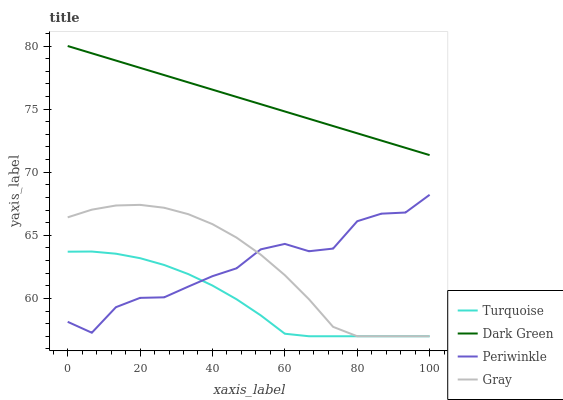Does Turquoise have the minimum area under the curve?
Answer yes or no. Yes. Does Dark Green have the maximum area under the curve?
Answer yes or no. Yes. Does Periwinkle have the minimum area under the curve?
Answer yes or no. No. Does Periwinkle have the maximum area under the curve?
Answer yes or no. No. Is Dark Green the smoothest?
Answer yes or no. Yes. Is Periwinkle the roughest?
Answer yes or no. Yes. Is Turquoise the smoothest?
Answer yes or no. No. Is Turquoise the roughest?
Answer yes or no. No. Does Gray have the lowest value?
Answer yes or no. Yes. Does Periwinkle have the lowest value?
Answer yes or no. No. Does Dark Green have the highest value?
Answer yes or no. Yes. Does Periwinkle have the highest value?
Answer yes or no. No. Is Turquoise less than Dark Green?
Answer yes or no. Yes. Is Dark Green greater than Periwinkle?
Answer yes or no. Yes. Does Gray intersect Turquoise?
Answer yes or no. Yes. Is Gray less than Turquoise?
Answer yes or no. No. Is Gray greater than Turquoise?
Answer yes or no. No. Does Turquoise intersect Dark Green?
Answer yes or no. No. 